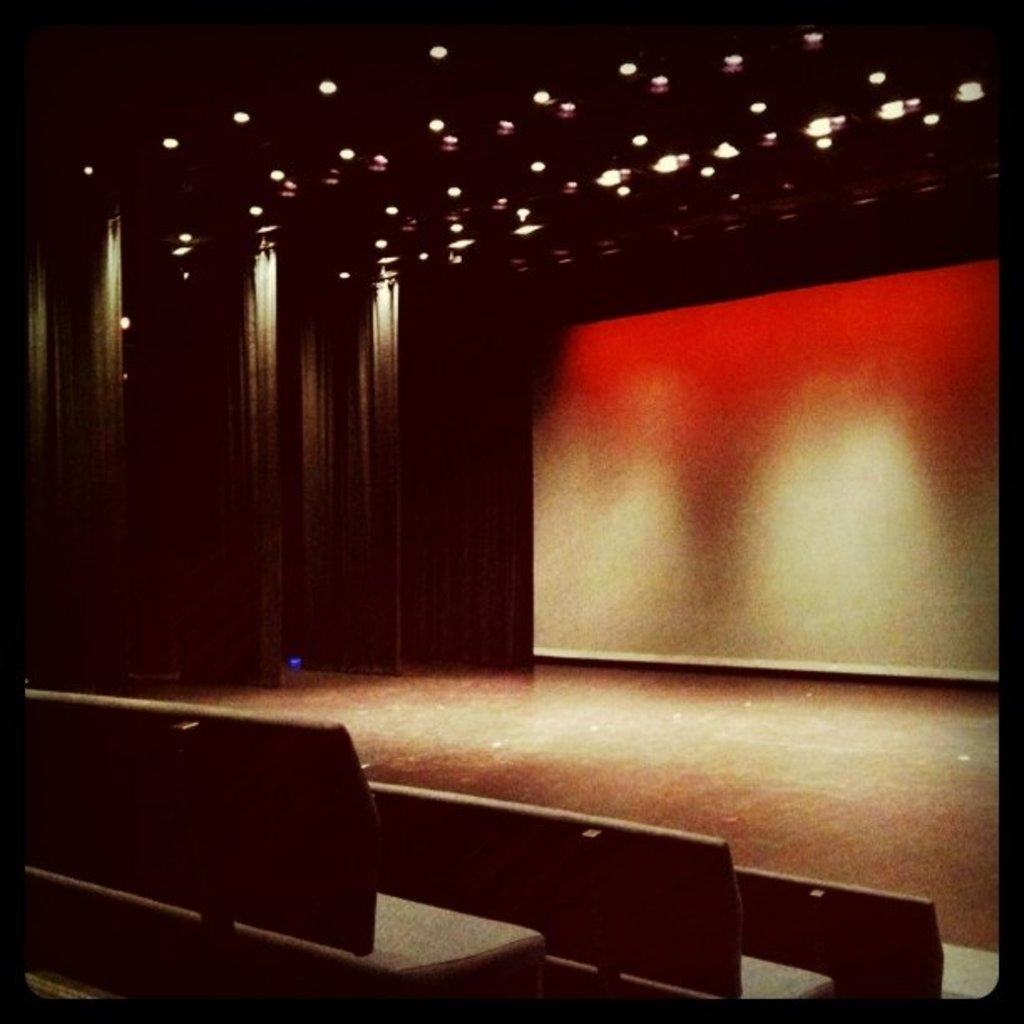Where was the image taken? The image was taken indoors. What can be seen in the foreground of the image? There are benches in the foreground of the image. What can be seen in the background of the image? Curtains, the roof, lights, and a wall are visible in the background of the image. How does the daughter feel about the temper of the amount of light in the image? There is no daughter present in the image, and the image does not convey any emotions or amounts related to the lighting. 